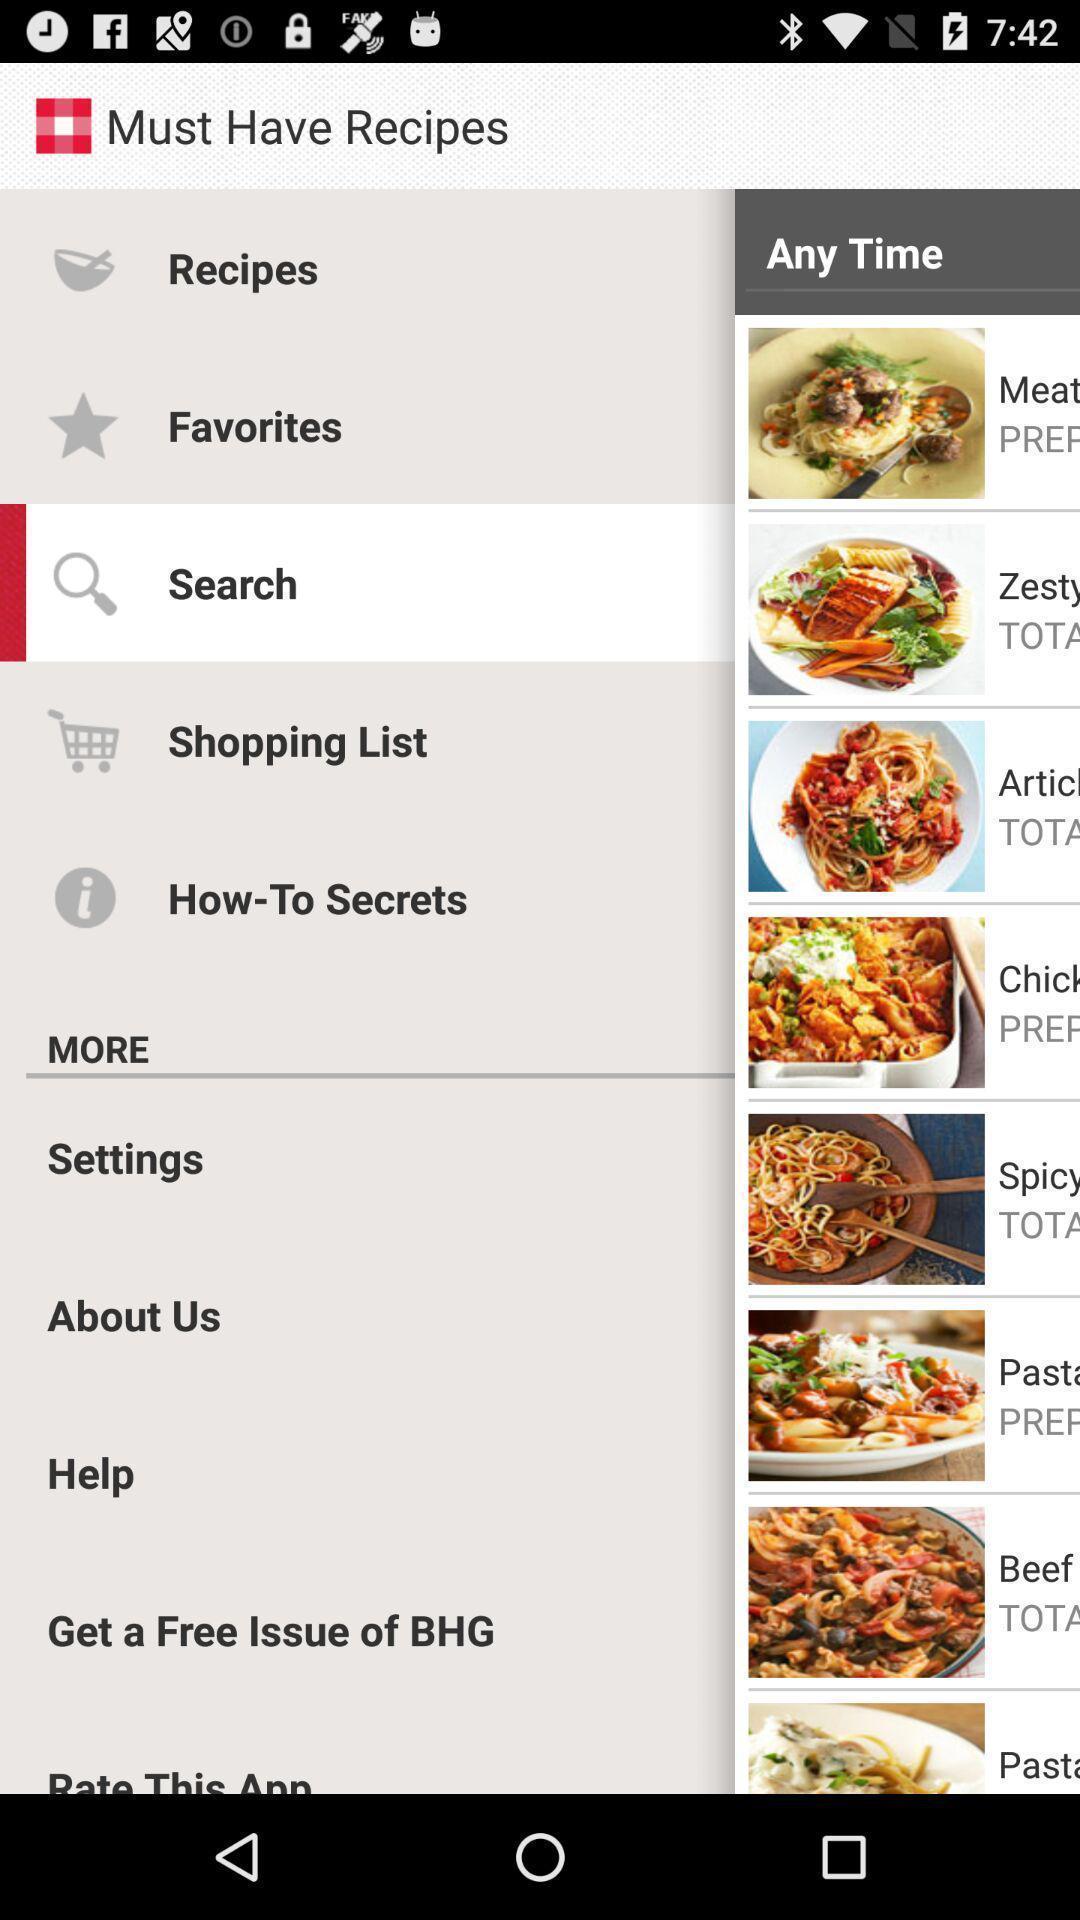Provide a description of this screenshot. Social app showing list of recipes. 